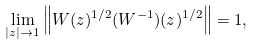<formula> <loc_0><loc_0><loc_500><loc_500>\lim _ { | z | \to 1 } \left \| W ( z ) ^ { 1 / 2 } ( W ^ { - 1 } ) ( z ) ^ { 1 / 2 } \right \| = 1 ,</formula> 